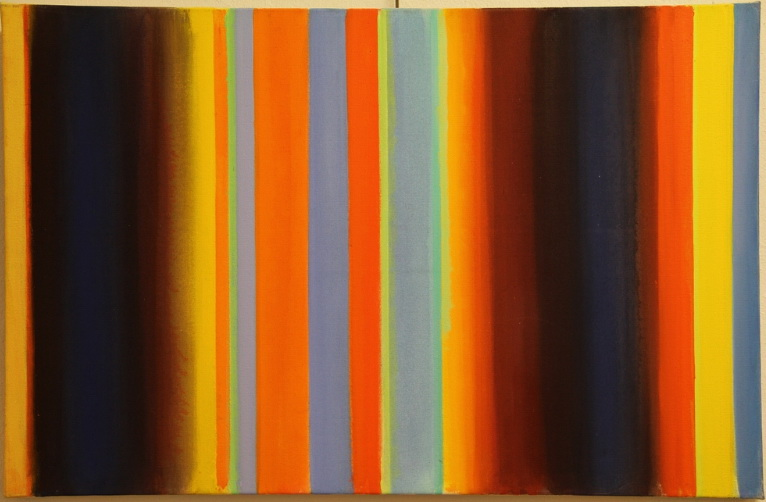Can you analyze how the variation in stripe widths contributes to the composition of the painting? The variation in stripe widths plays a crucial role in creating visual interest and maintaining viewer engagement. Narrower stripes may evoke a sense of delicacy or tension, while wider stripes provide a sense of stability and calm. This interplay between the different widths adds a structural rhythm to the painting, making the viewer's eye travel across the canvas and inviting them to interpret the spaces in between the lines. It subtly commands attention and suggests movement, contributing to the overall dynamism of the piece. 